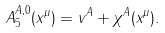<formula> <loc_0><loc_0><loc_500><loc_500>A _ { 5 } ^ { A , 0 } ( x ^ { \mu } ) = v ^ { A } + \chi ^ { A } ( x ^ { \mu } ) .</formula> 